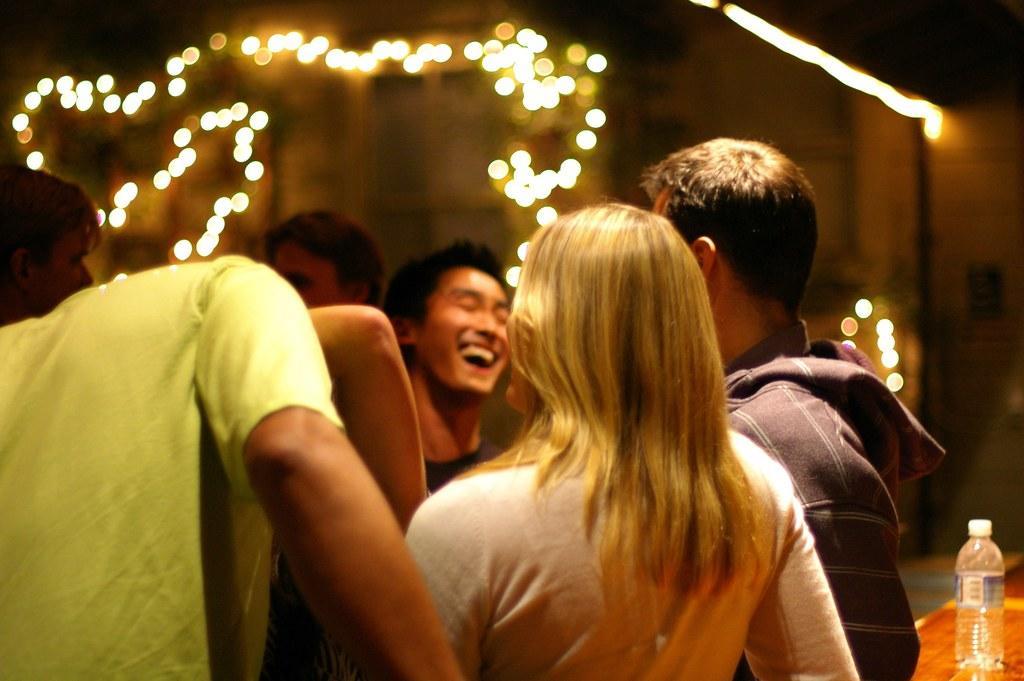How would you summarize this image in a sentence or two? It is a party group of people standing and chit chatting,in the background there are some lights, behind the people there is a table and a bottle on the table. 